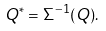<formula> <loc_0><loc_0><loc_500><loc_500>Q ^ { * } = \Sigma ^ { - 1 } ( Q ) .</formula> 